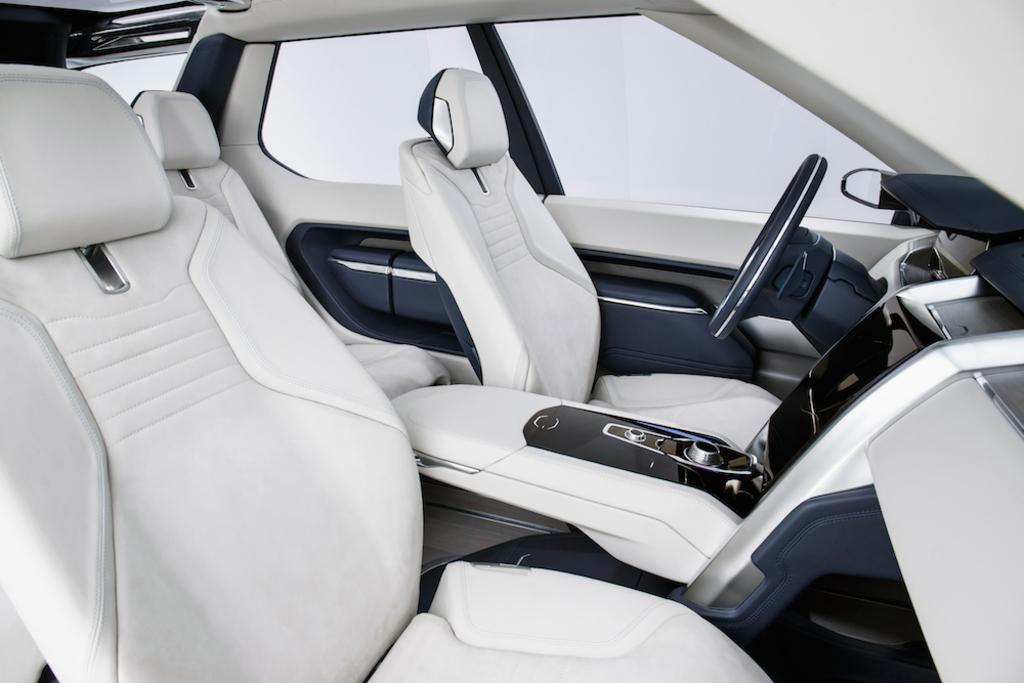What type of vehicle is shown in the image? The image shows an inside view of a car. What can be found inside the car? There are seats and a steering wheel in the car. Can you describe any other items or features in the car? Other unspecified things are present in the car. How far away is the nearest jellyfish from the car in the image? There are no jellyfish present in the image, as it shows an inside view of a car. 